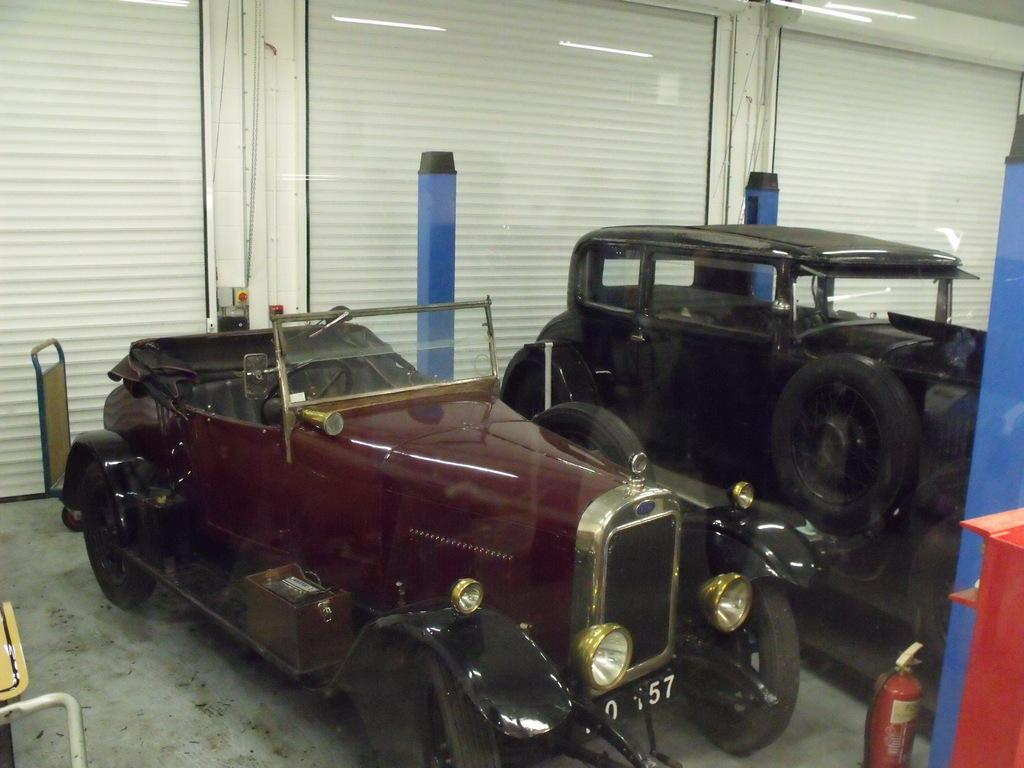How many vehicles can be seen in the image? There are two vehicles in the image. What safety device is present in the image? There is a fire extinguisher in the image. What type of architectural feature is visible in the background of the image? There are shutters in the background of the image. What type of illumination is present in the background of the image? There are lights in the background of the image. What type of knot is being used to secure the vehicles in the image? There is no knot visible in the image; the vehicles are not tied together. 